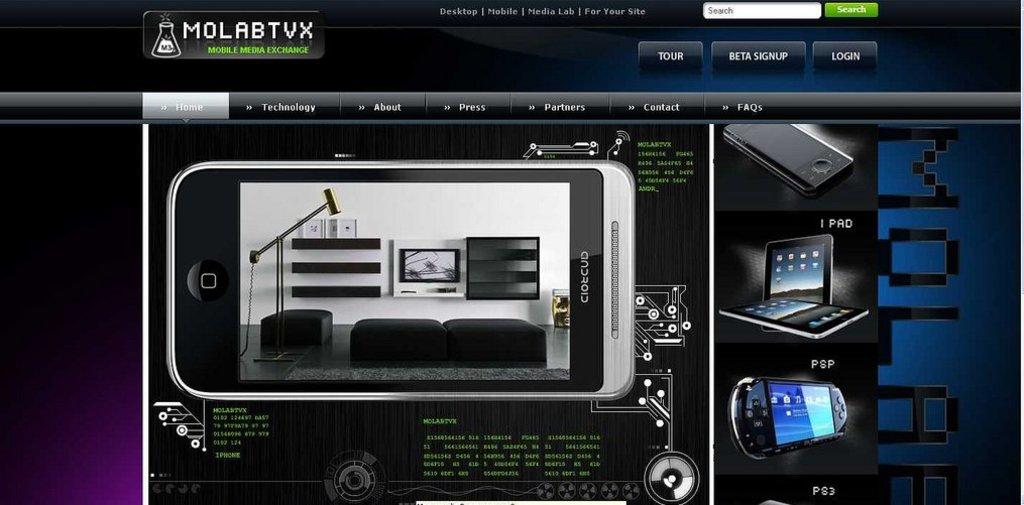What is the name of the website?
Offer a terse response. Molabtvx. Can you login on this page?
Make the answer very short. Yes. 